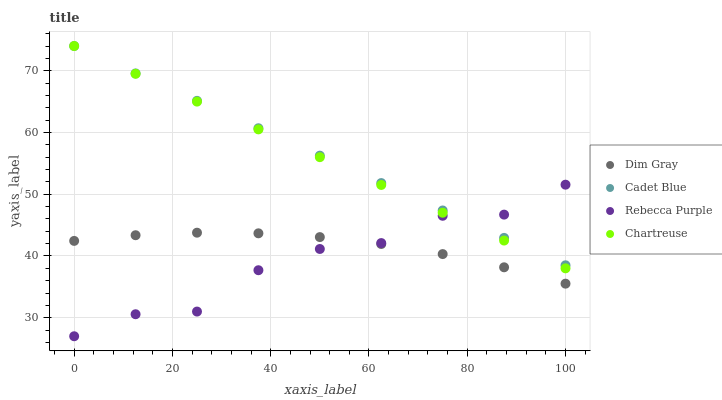Does Rebecca Purple have the minimum area under the curve?
Answer yes or no. Yes. Does Cadet Blue have the maximum area under the curve?
Answer yes or no. Yes. Does Chartreuse have the minimum area under the curve?
Answer yes or no. No. Does Chartreuse have the maximum area under the curve?
Answer yes or no. No. Is Cadet Blue the smoothest?
Answer yes or no. Yes. Is Rebecca Purple the roughest?
Answer yes or no. Yes. Is Chartreuse the smoothest?
Answer yes or no. No. Is Chartreuse the roughest?
Answer yes or no. No. Does Rebecca Purple have the lowest value?
Answer yes or no. Yes. Does Chartreuse have the lowest value?
Answer yes or no. No. Does Chartreuse have the highest value?
Answer yes or no. Yes. Does Dim Gray have the highest value?
Answer yes or no. No. Is Dim Gray less than Chartreuse?
Answer yes or no. Yes. Is Chartreuse greater than Dim Gray?
Answer yes or no. Yes. Does Rebecca Purple intersect Dim Gray?
Answer yes or no. Yes. Is Rebecca Purple less than Dim Gray?
Answer yes or no. No. Is Rebecca Purple greater than Dim Gray?
Answer yes or no. No. Does Dim Gray intersect Chartreuse?
Answer yes or no. No. 